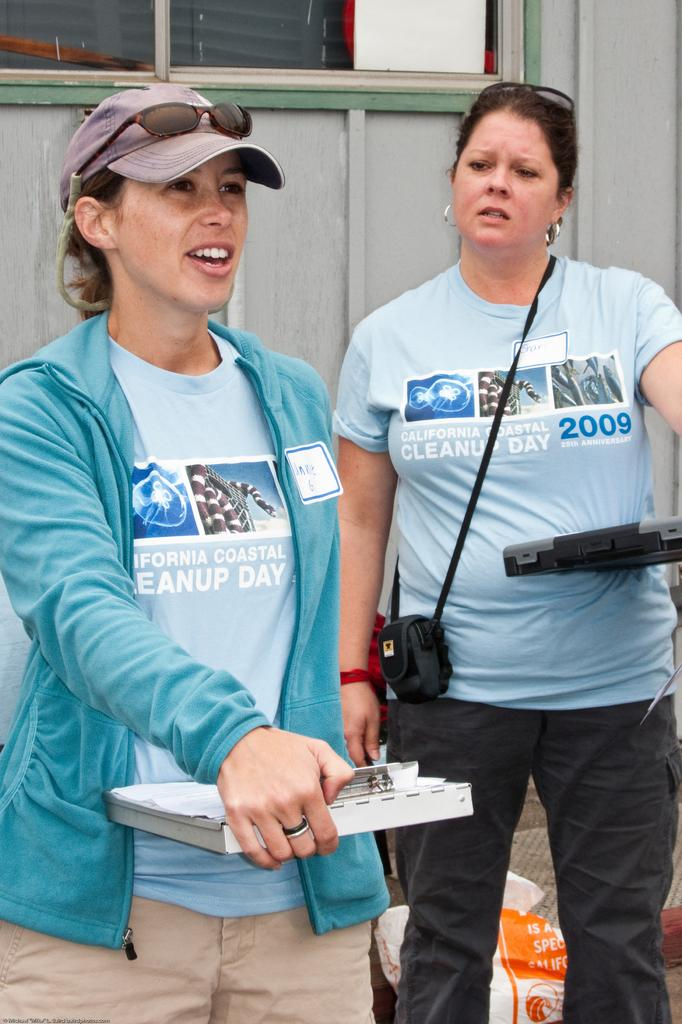<image>
Create a compact narrative representing the image presented. Two women wearing tee shirts for the California Coastal Cleanup Day from 2009. 